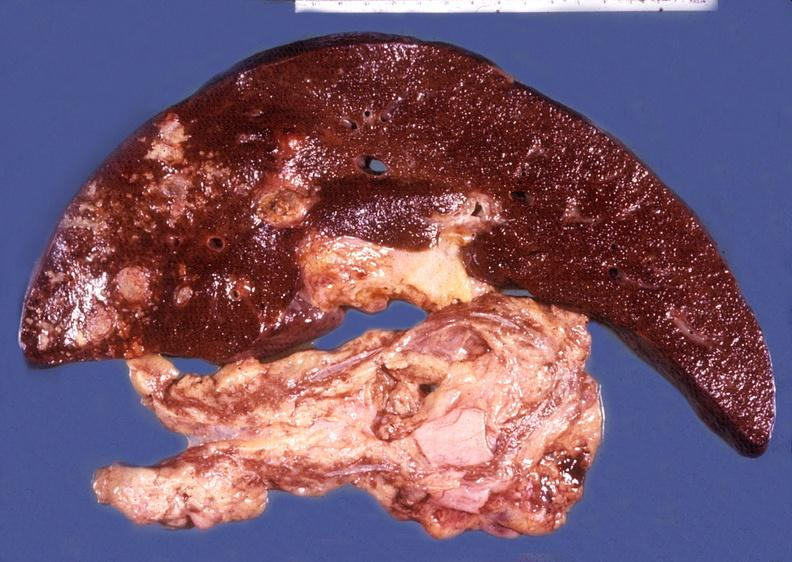what is present?
Answer the question using a single word or phrase. Hepatobiliary 